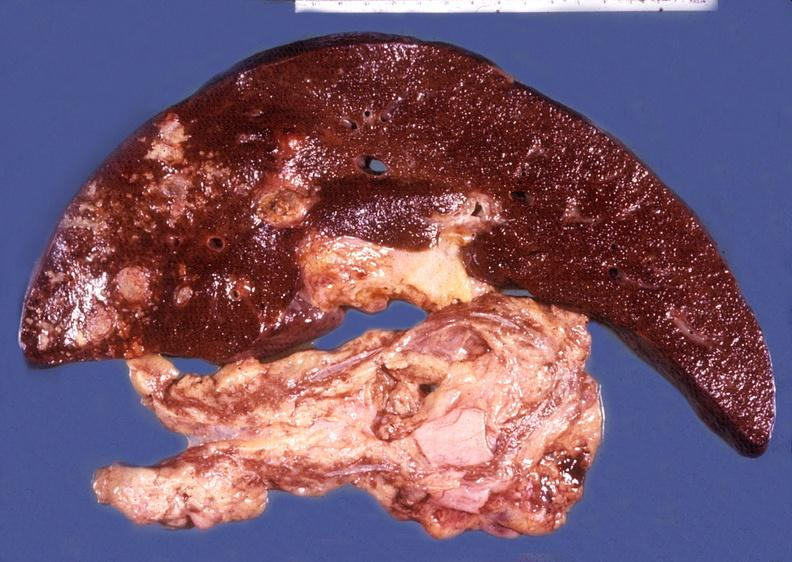what is present?
Answer the question using a single word or phrase. Hepatobiliary 